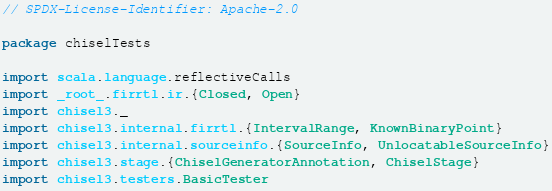Convert code to text. <code><loc_0><loc_0><loc_500><loc_500><_Scala_>// SPDX-License-Identifier: Apache-2.0

package chiselTests

import scala.language.reflectiveCalls
import _root_.firrtl.ir.{Closed, Open}
import chisel3._
import chisel3.internal.firrtl.{IntervalRange, KnownBinaryPoint}
import chisel3.internal.sourceinfo.{SourceInfo, UnlocatableSourceInfo}
import chisel3.stage.{ChiselGeneratorAnnotation, ChiselStage}
import chisel3.testers.BasicTester</code> 